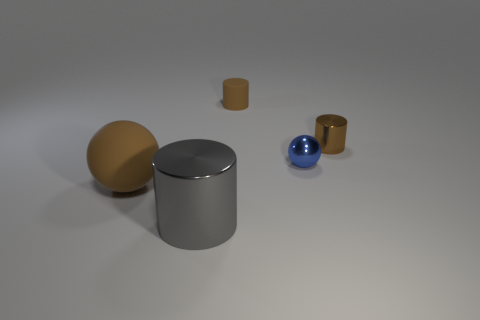Add 5 blue shiny balls. How many objects exist? 10 Subtract all cylinders. How many objects are left? 2 Add 4 small brown matte things. How many small brown matte things exist? 5 Subtract 0 purple cylinders. How many objects are left? 5 Subtract all brown cylinders. Subtract all big brown rubber spheres. How many objects are left? 2 Add 3 brown balls. How many brown balls are left? 4 